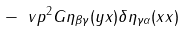<formula> <loc_0><loc_0><loc_500><loc_500>- \ v p { ^ { 2 } G } { \eta _ { \beta \gamma } ( y x ) \delta \eta _ { \gamma \alpha } ( x x ) } \,</formula> 